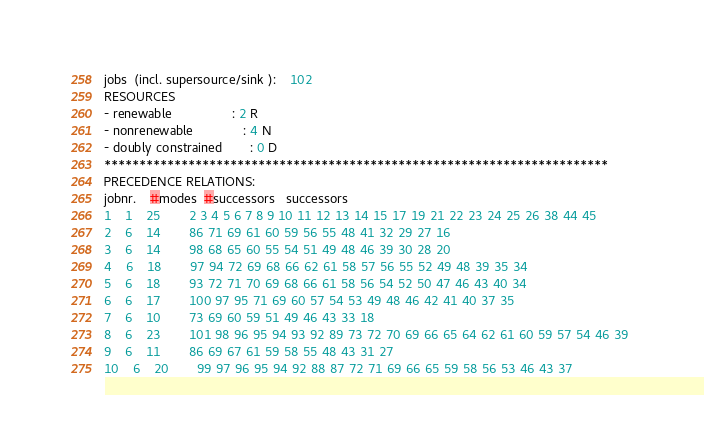<code> <loc_0><loc_0><loc_500><loc_500><_ObjectiveC_>jobs  (incl. supersource/sink ):	102
RESOURCES
- renewable                 : 2 R
- nonrenewable              : 4 N
- doubly constrained        : 0 D
************************************************************************
PRECEDENCE RELATIONS:
jobnr.    #modes  #successors   successors
1	1	25		2 3 4 5 6 7 8 9 10 11 12 13 14 15 17 19 21 22 23 24 25 26 38 44 45 
2	6	14		86 71 69 61 60 59 56 55 48 41 32 29 27 16 
3	6	14		98 68 65 60 55 54 51 49 48 46 39 30 28 20 
4	6	18		97 94 72 69 68 66 62 61 58 57 56 55 52 49 48 39 35 34 
5	6	18		93 72 71 70 69 68 66 61 58 56 54 52 50 47 46 43 40 34 
6	6	17		100 97 95 71 69 60 57 54 53 49 48 46 42 41 40 37 35 
7	6	10		73 69 60 59 51 49 46 43 33 18 
8	6	23		101 98 96 95 94 93 92 89 73 72 70 69 66 65 64 62 61 60 59 57 54 46 39 
9	6	11		86 69 67 61 59 58 55 48 43 31 27 
10	6	20		99 97 96 95 94 92 88 87 72 71 69 66 65 59 58 56 53 46 43 37 </code> 